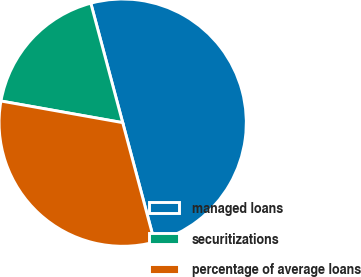Convert chart. <chart><loc_0><loc_0><loc_500><loc_500><pie_chart><fcel>managed loans<fcel>securitizations<fcel>percentage of average loans<nl><fcel>50.0%<fcel>18.05%<fcel>31.95%<nl></chart> 